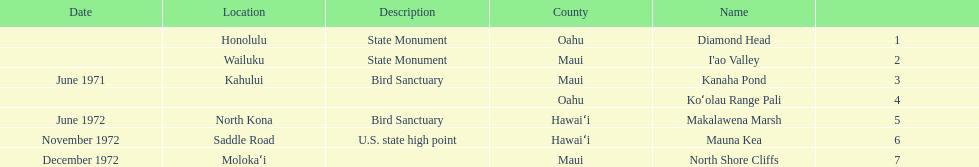Which county is featured the most on the chart? Maui. 